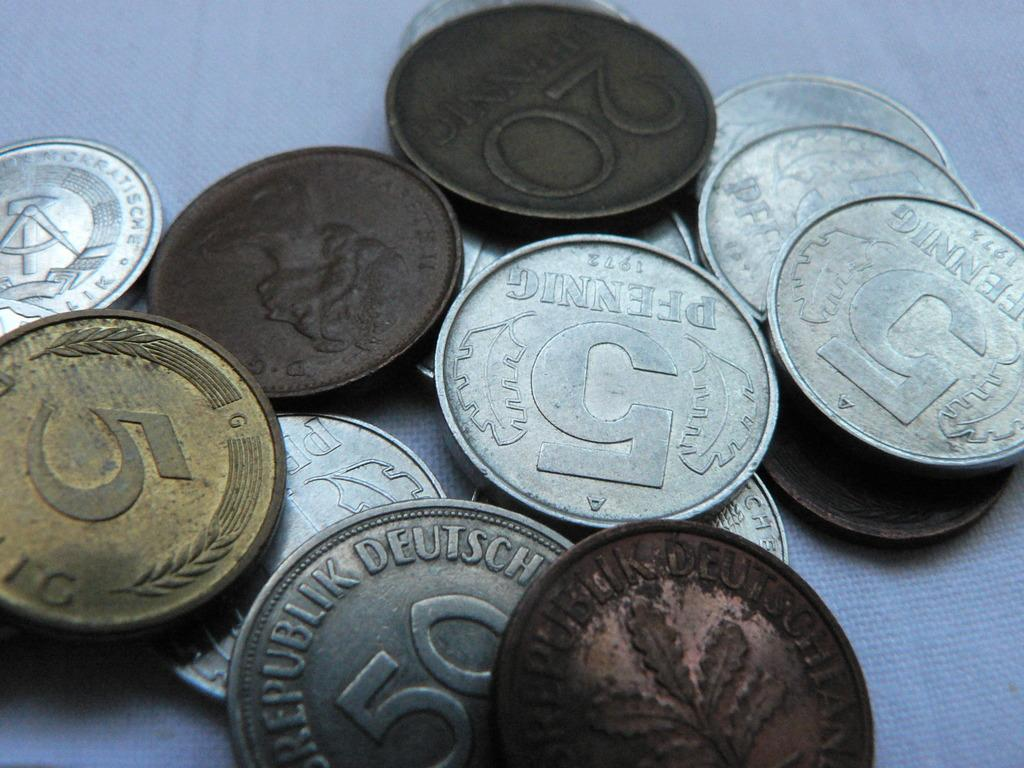<image>
Summarize the visual content of the image. many coins on a table reading 5 and 20 Pfennig 